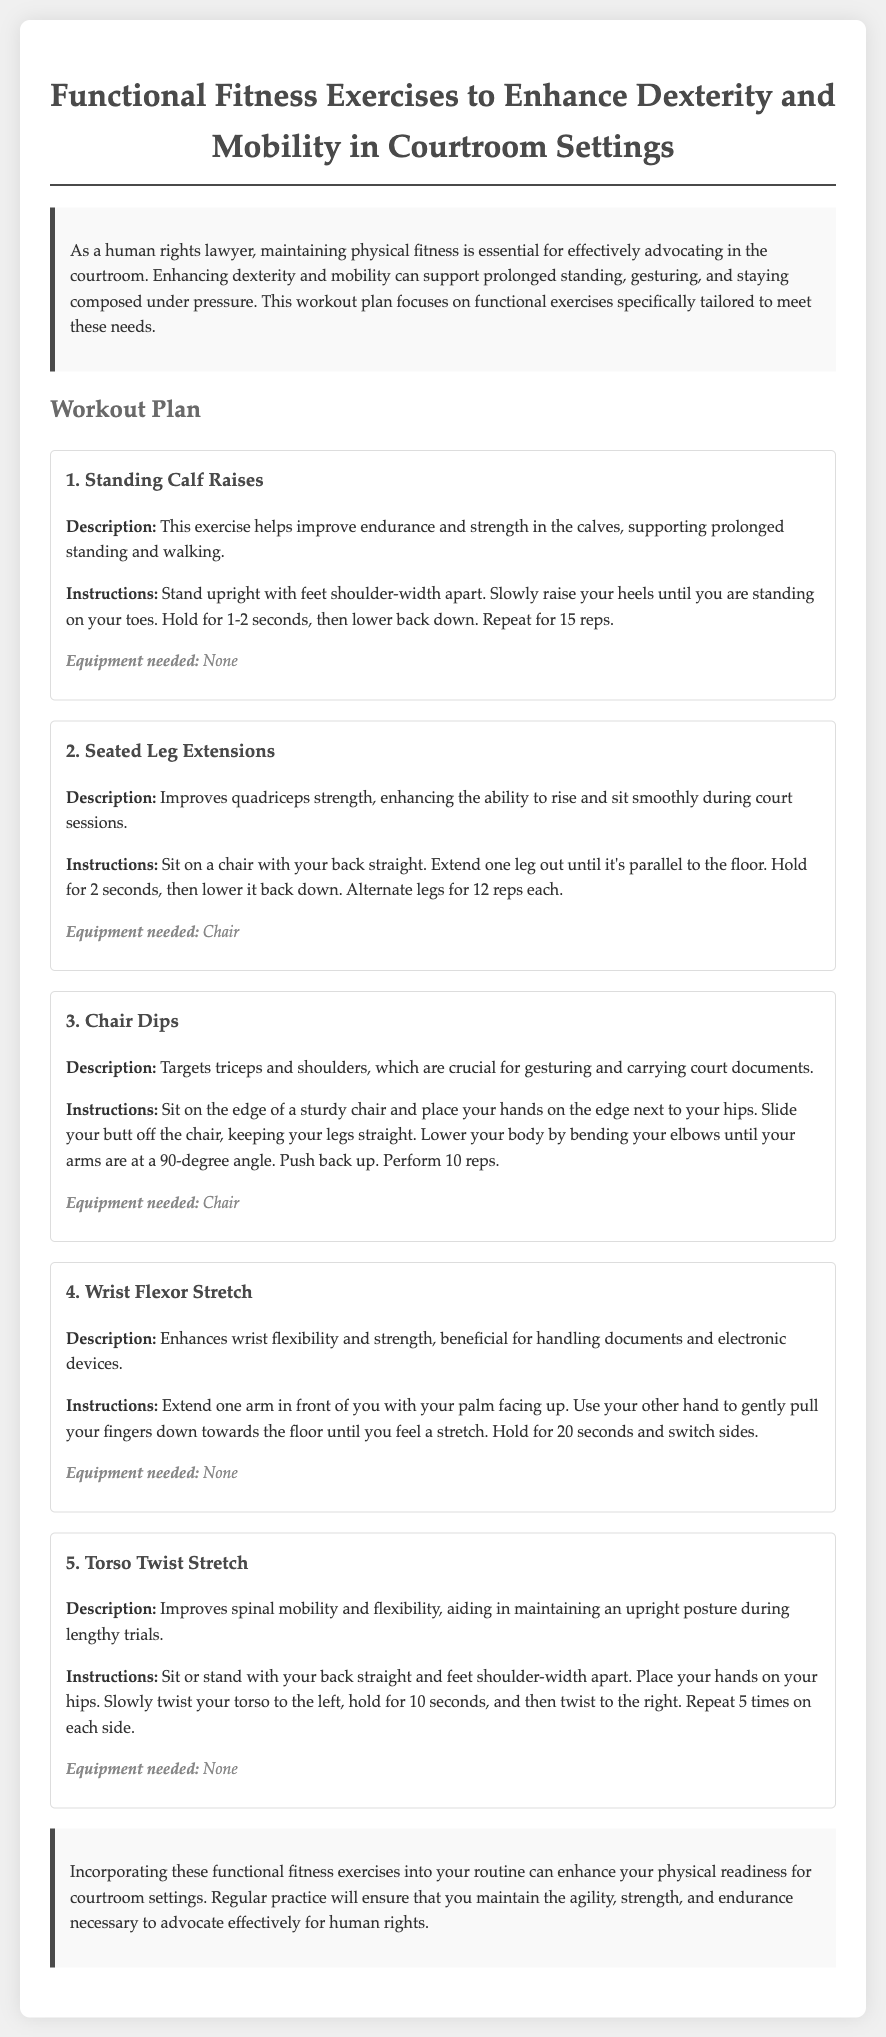what is the title of the document? The title is mentioned at the top of the document, providing a clear subject focus.
Answer: Functional Fitness Exercises to Enhance Dexterity and Mobility in Courtroom Settings how many exercises are included in the workout plan? The document lists a total of four specific exercises designed for functional fitness.
Answer: 5 what is the equipment needed for Standing Calf Raises? The document states the requirements for each exercise, and this particular one does not need any equipment.
Answer: None what is the primary benefit of Seated Leg Extensions? The description explains that this exercise improves quadriceps strength, enhancing movement during court sessions.
Answer: Quadriceps strength how long should you hold the Wrist Flexor Stretch? The instruction specifies the duration for which one should hold the stretch to gain maximum benefit.
Answer: 20 seconds which exercise targets triceps and shoulders? The title and description clearly identify which exercise focuses on these muscle groups, aiding in gesturing and carrying documents.
Answer: Chair Dips what is the maximum number of repetitions for Chair Dips? The instruction provides a specific number of times to perform this exercise to ensure effectiveness.
Answer: 10 reps what does Torso Twist Stretch improve? The description highlights that this stretch helps with spinal mobility and flexibility, crucial during lengthy trials.
Answer: Spinal mobility and flexibility what enhances wrist flexibility according to the document? The exercise that is specifically designed to improve wrist flexibility is mentioned within the workout plan.
Answer: Wrist Flexor Stretch 